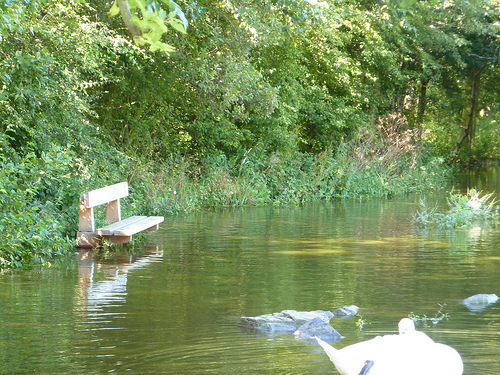<image>
Is the grass in the water? Yes. The grass is contained within or inside the water, showing a containment relationship. 